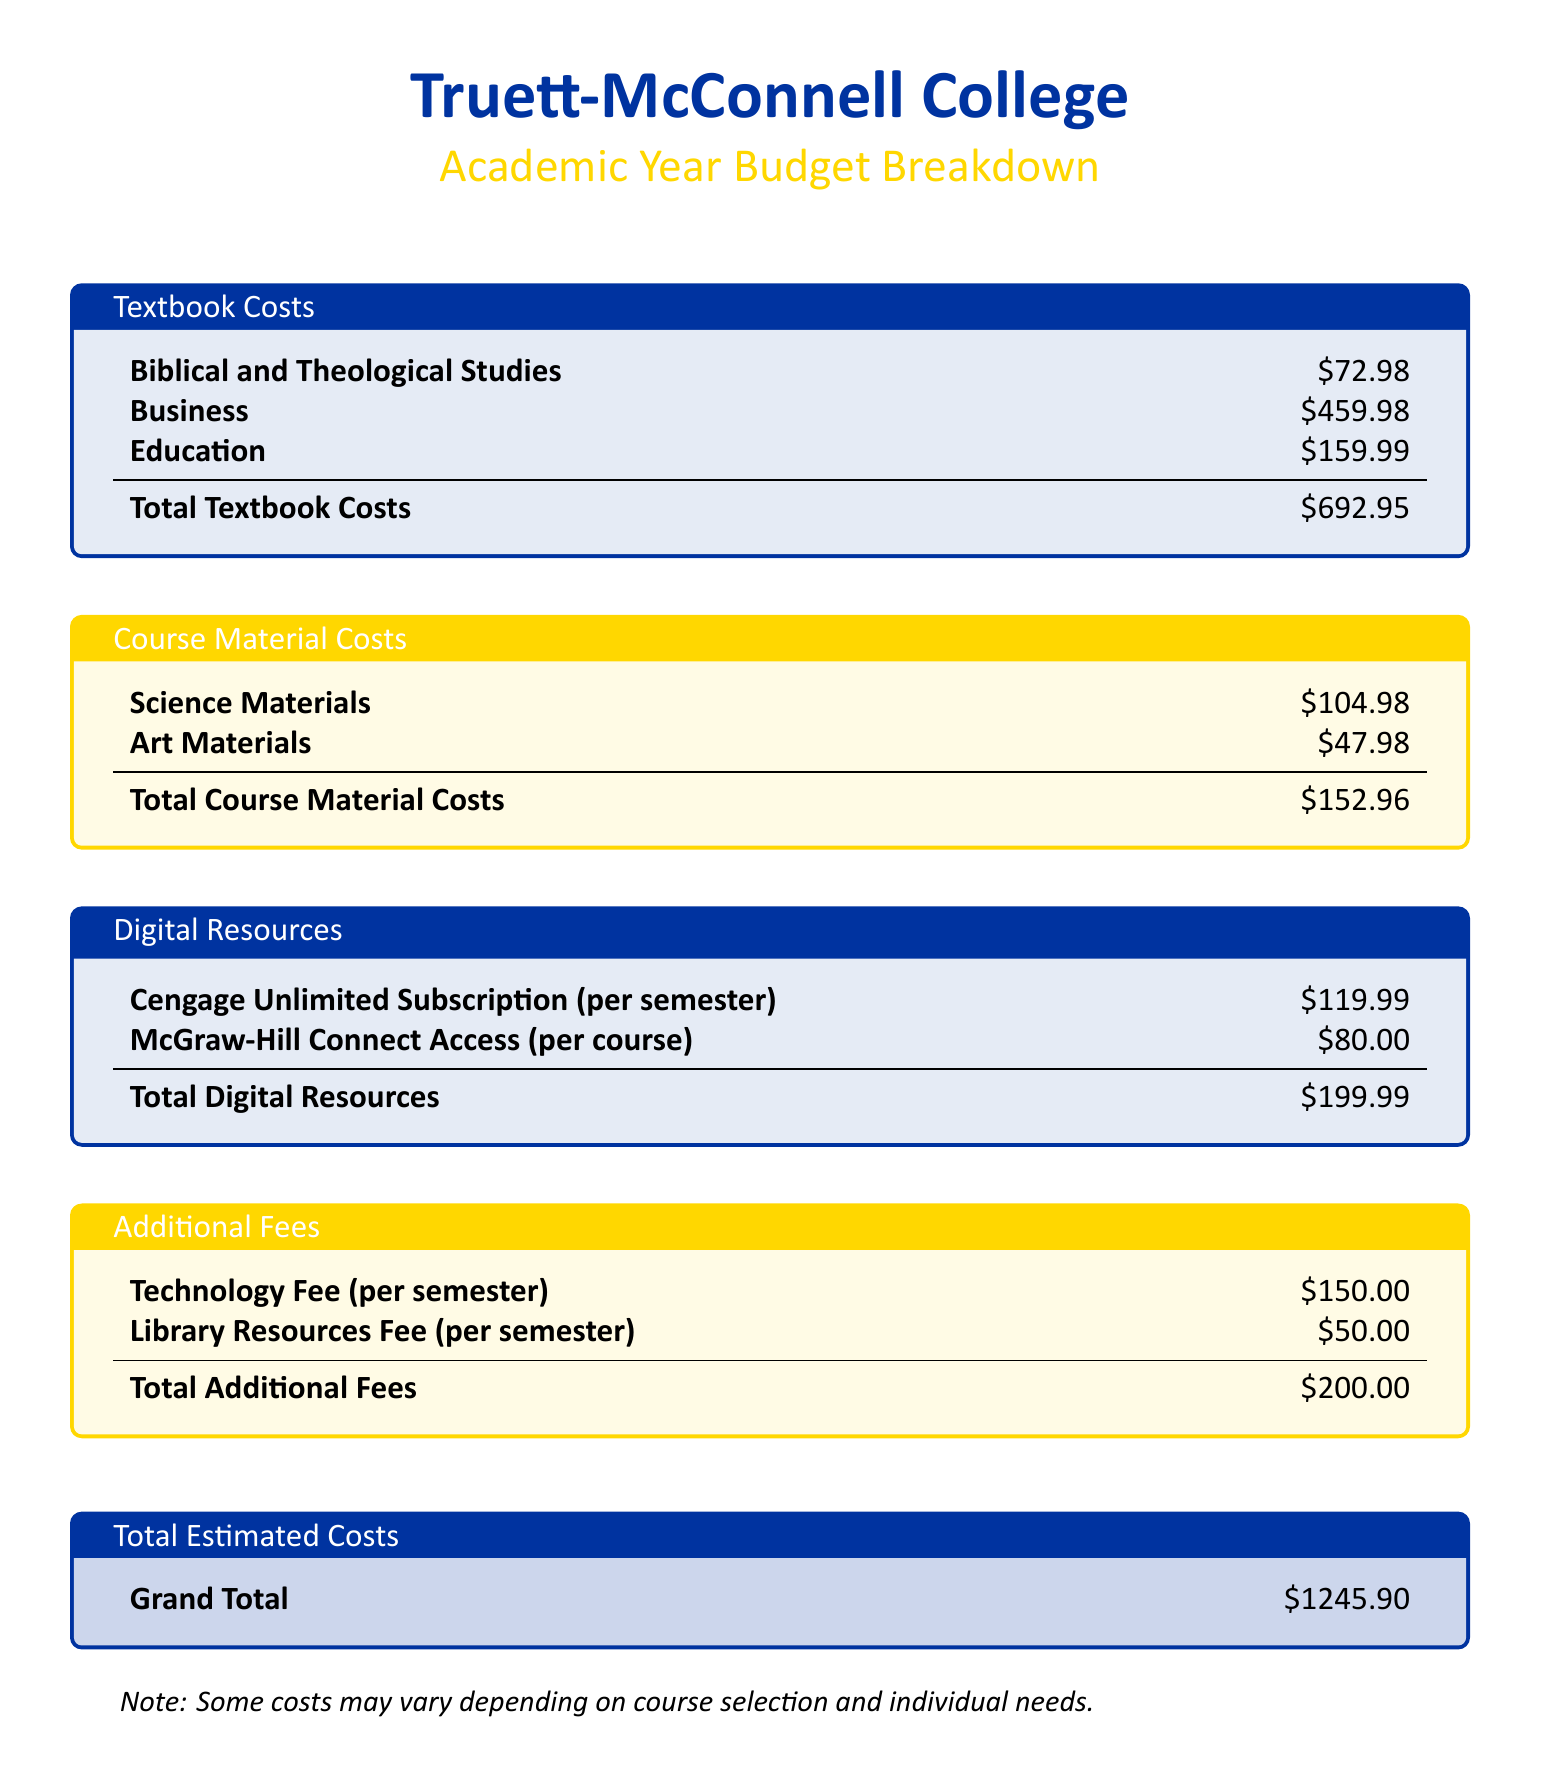What is the total textbook cost? The total textbook cost is provided at the end of the textbook section, which sums the individual textbook costs.
Answer: $692.95 What is the cost of Business textbooks? The cost of Business textbooks is listed explicitly in the document.
Answer: $459.98 How much are the Science materials? The amount for Science materials is specified in the course material section of the budget.
Answer: $104.98 What are the total additional fees? The total additional fees are the combined total from the additional fees section.
Answer: $200.00 What is the total estimated cost? The total estimated cost is the grand total presented at the end of the budget document.
Answer: $1245.90 How much does a Cengage Unlimited subscription cost per semester? The cost of a Cengage Unlimited subscription per semester is clearly stated in the digital resources section.
Answer: $119.99 What is the cost of Art materials? The cost of Art materials is found in the course material costs section of the budget.
Answer: $47.98 What is included in the Digital Resources? The digital resources include two specific items listed, one of which is the Cengage Unlimited subscription.
Answer: Cengage Unlimited Subscription Which category has the highest cost? To identify the highest cost category, one must compare the total costs of all sections.
Answer: Textbook Costs What is the total cost of Library Resources fee per semester? The Library Resources Fee is mentioned in the additional fees section.
Answer: $50.00 